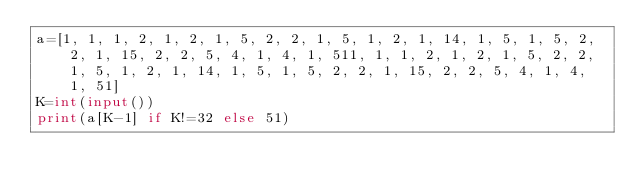<code> <loc_0><loc_0><loc_500><loc_500><_Python_>a=[1, 1, 1, 2, 1, 2, 1, 5, 2, 2, 1, 5, 1, 2, 1, 14, 1, 5, 1, 5, 2, 2, 1, 15, 2, 2, 5, 4, 1, 4, 1, 511, 1, 1, 2, 1, 2, 1, 5, 2, 2, 1, 5, 1, 2, 1, 14, 1, 5, 1, 5, 2, 2, 1, 15, 2, 2, 5, 4, 1, 4, 1, 51]
K=int(input())
print(a[K-1] if K!=32 else 51)</code> 